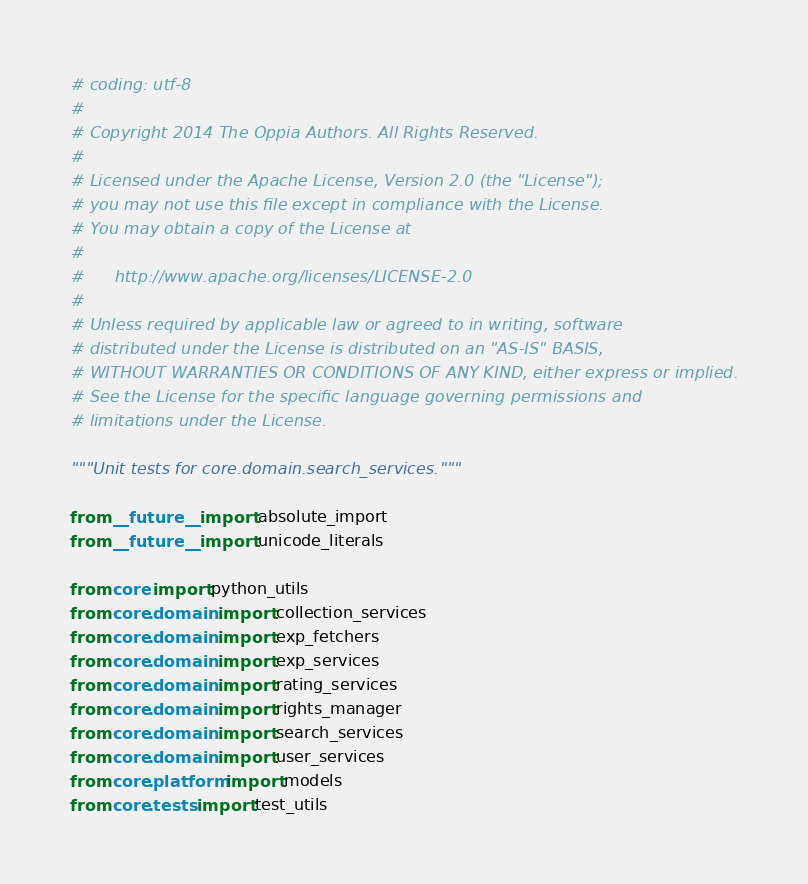Convert code to text. <code><loc_0><loc_0><loc_500><loc_500><_Python_># coding: utf-8
#
# Copyright 2014 The Oppia Authors. All Rights Reserved.
#
# Licensed under the Apache License, Version 2.0 (the "License");
# you may not use this file except in compliance with the License.
# You may obtain a copy of the License at
#
#      http://www.apache.org/licenses/LICENSE-2.0
#
# Unless required by applicable law or agreed to in writing, software
# distributed under the License is distributed on an "AS-IS" BASIS,
# WITHOUT WARRANTIES OR CONDITIONS OF ANY KIND, either express or implied.
# See the License for the specific language governing permissions and
# limitations under the License.

"""Unit tests for core.domain.search_services."""

from __future__ import absolute_import
from __future__ import unicode_literals

from core import python_utils
from core.domain import collection_services
from core.domain import exp_fetchers
from core.domain import exp_services
from core.domain import rating_services
from core.domain import rights_manager
from core.domain import search_services
from core.domain import user_services
from core.platform import models
from core.tests import test_utils
</code> 